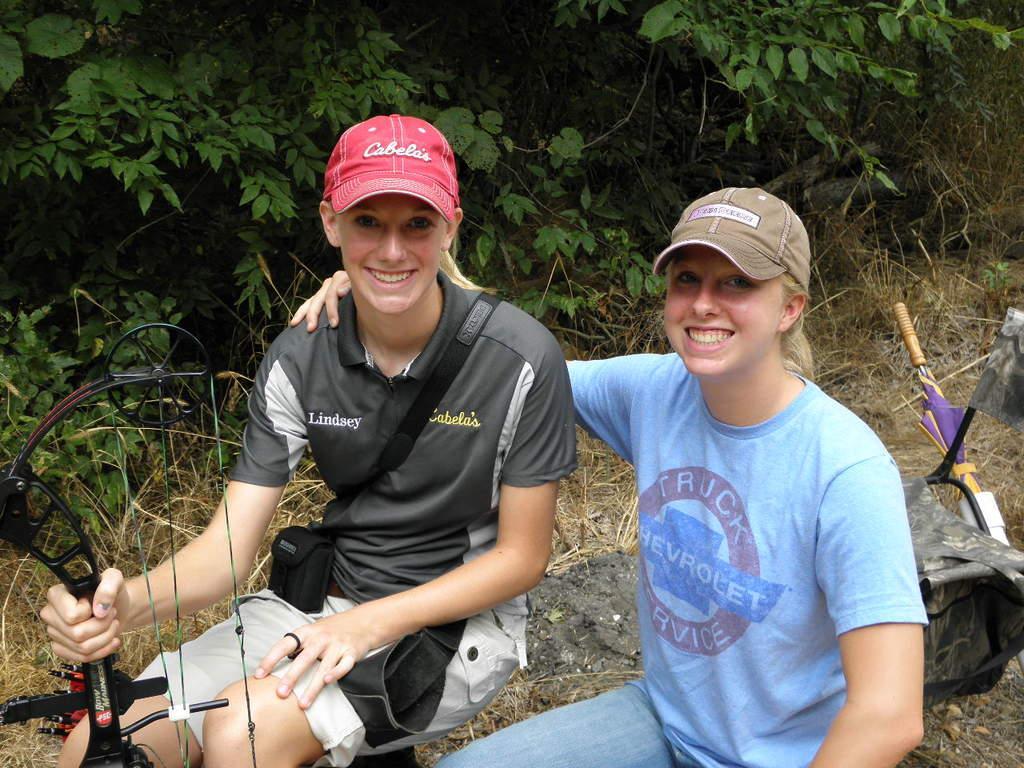Could you give a brief overview of what you see in this image? In this picture we can see two girls wore caps and sitting and smiling, bag, arrow, umbrella and an object on the ground and in the background we can see the grass, trees. 